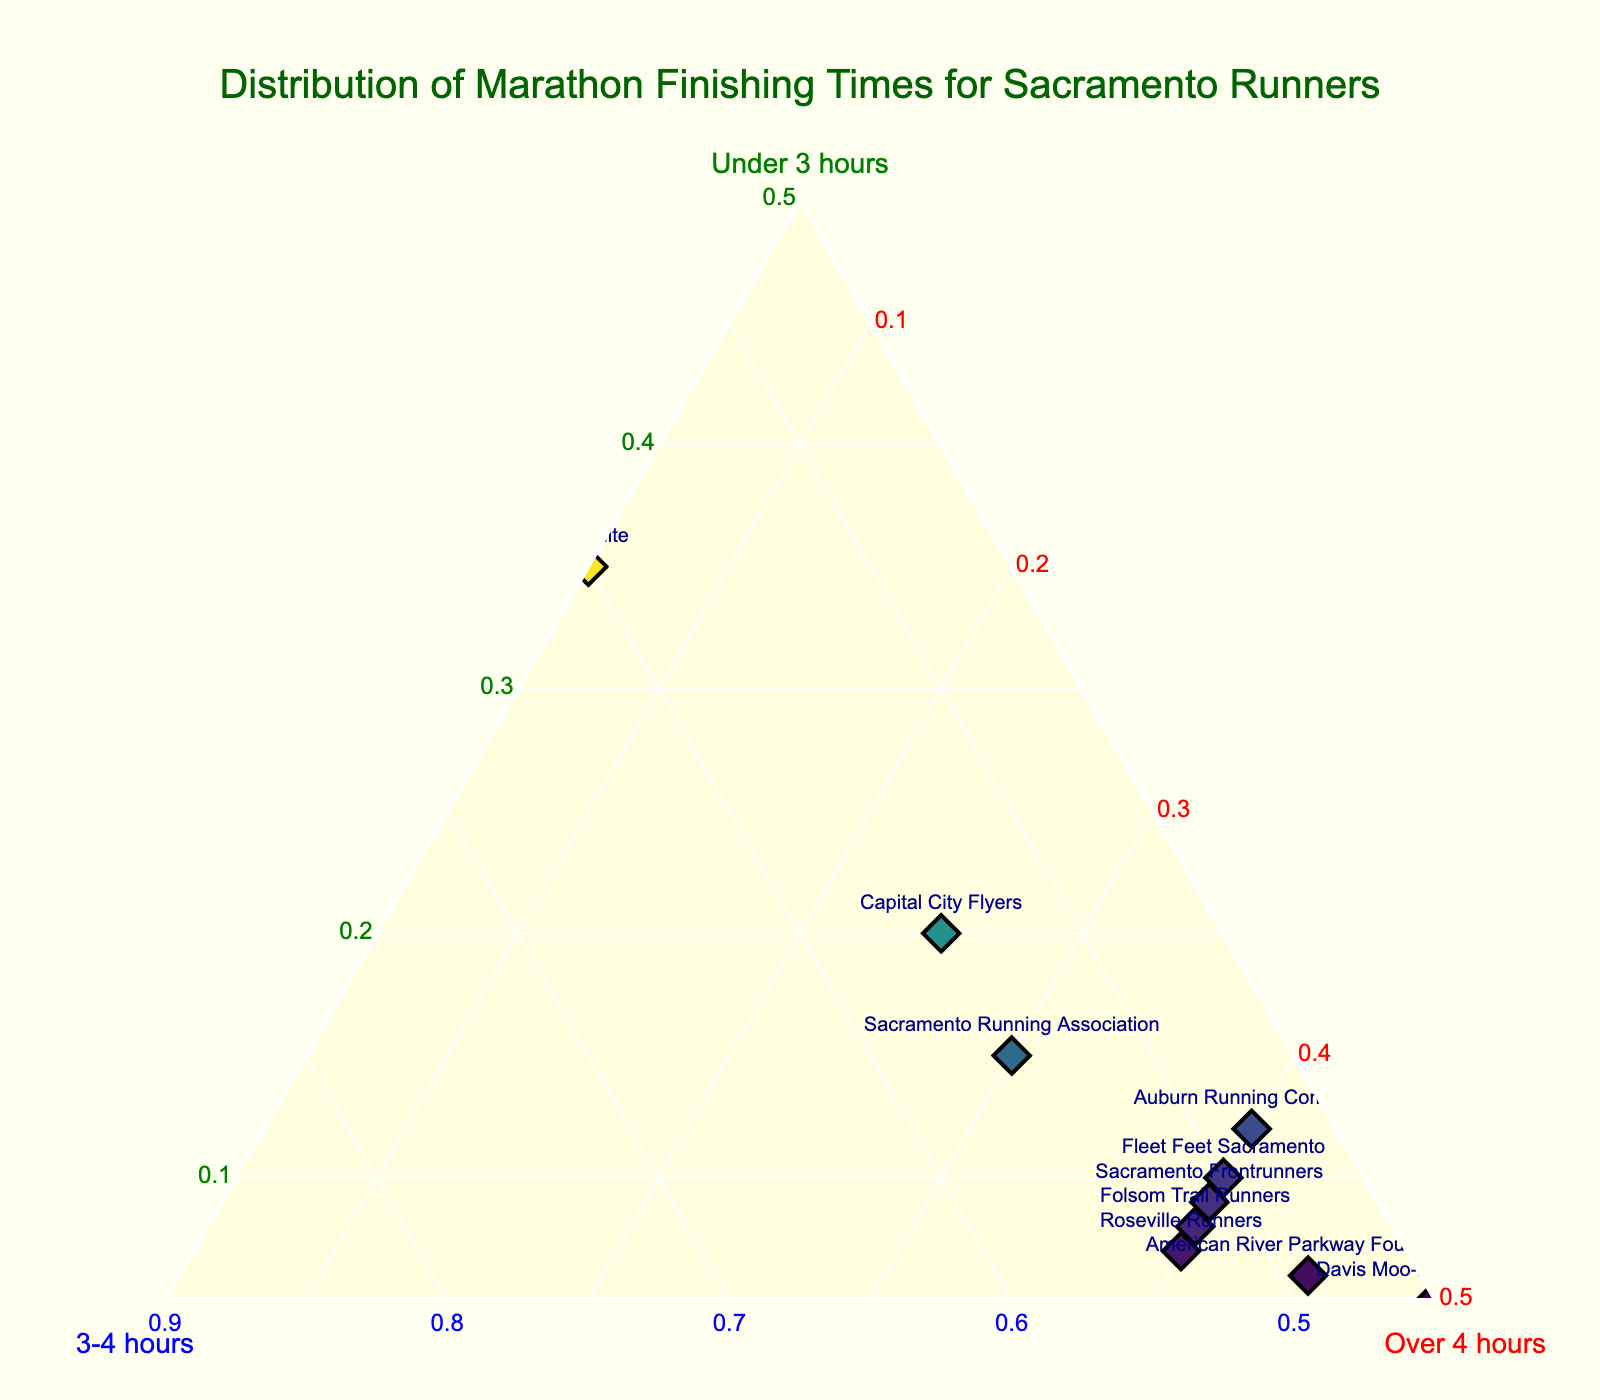What is the title of the plot? The title is located at the top center of the plot in bold green text.
Answer: Distribution of Marathon Finishing Times for Sacramento Runners How many runner groups are represented in the plot? The number of data points (markers) corresponds to the number of runner groups, each labeled with their name.
Answer: 10 Which runner group has the highest proportion of finishers under 3 hours? You need to find the marker with the highest value on the under 3 hours axis (represented by the 'a' axis).
Answer: CIM Elite What is the difference in the proportion of finishers under 3 hours between CIM Elite and Fleet Feet Sacramento? Find the proportions for both groups on the under 3 hours axis (0.35 - 0.10).
Answer: 0.25 Which group has the smallest proportion of finishers over 4 hours? Look at the 'c' axis to determine the smallest value.
Answer: CIM Elite What is the average proportion of finishers under 3 hours across all runner groups? Sum all the percentages of under 3 hours and divide by the number of runner groups: (0.35 + 0.15 + 0.10 + 0.05 + 0.08 + 0.12 + 0.20 + 0.07 + 0.09 + 0.06) / 10 = 0.127
Answer: 0.127 Which runner group is positioned closest to having equal proportions across all three categories? Identify the group whose marker is closest to the center of the triangle, indicating balance.
Answer: Sacramento Running Association How does the Folsom Trail Runners' distribution compare to the Davis Moo-nlight Run Club's? Compare the percentages for each group from the 'a', 'b', and 'c' values: Folsom Trail Runners (0.08, 0.52, 0.40) and Davis Moo-nlight Run Club (0.05, 0.45, 0.50). Both have more finishers above 3 hours, but Davis Moo-nlight Run Club has more in over 4 hours.
Answer: Davis Moo-nlight Run Club has fewer finishers under 3 hours and more over 4 hours What is the proportion difference of finishers between 3-4 hours for the Sacramento Running Association and Auburn Running Company? Compare the 'b' values: Sacramento Running Association (0.55) minus Auburn Running Company (0.48) = 0.07
Answer: 0.07 